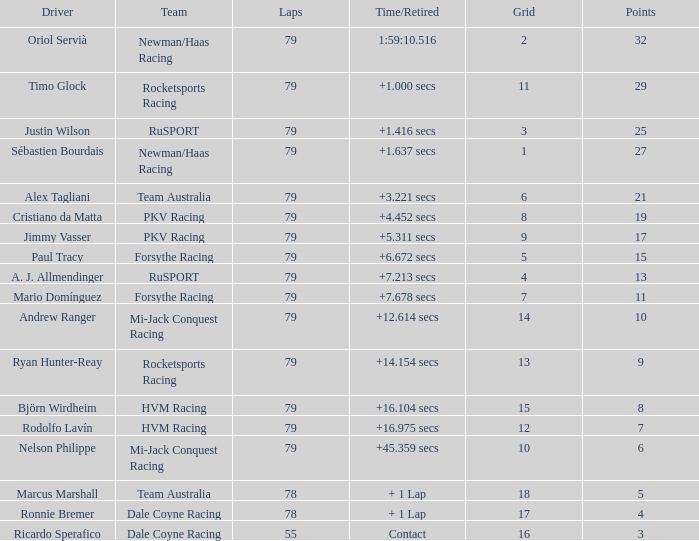Can you provide the points earned by the driver paul tracy? 15.0. 